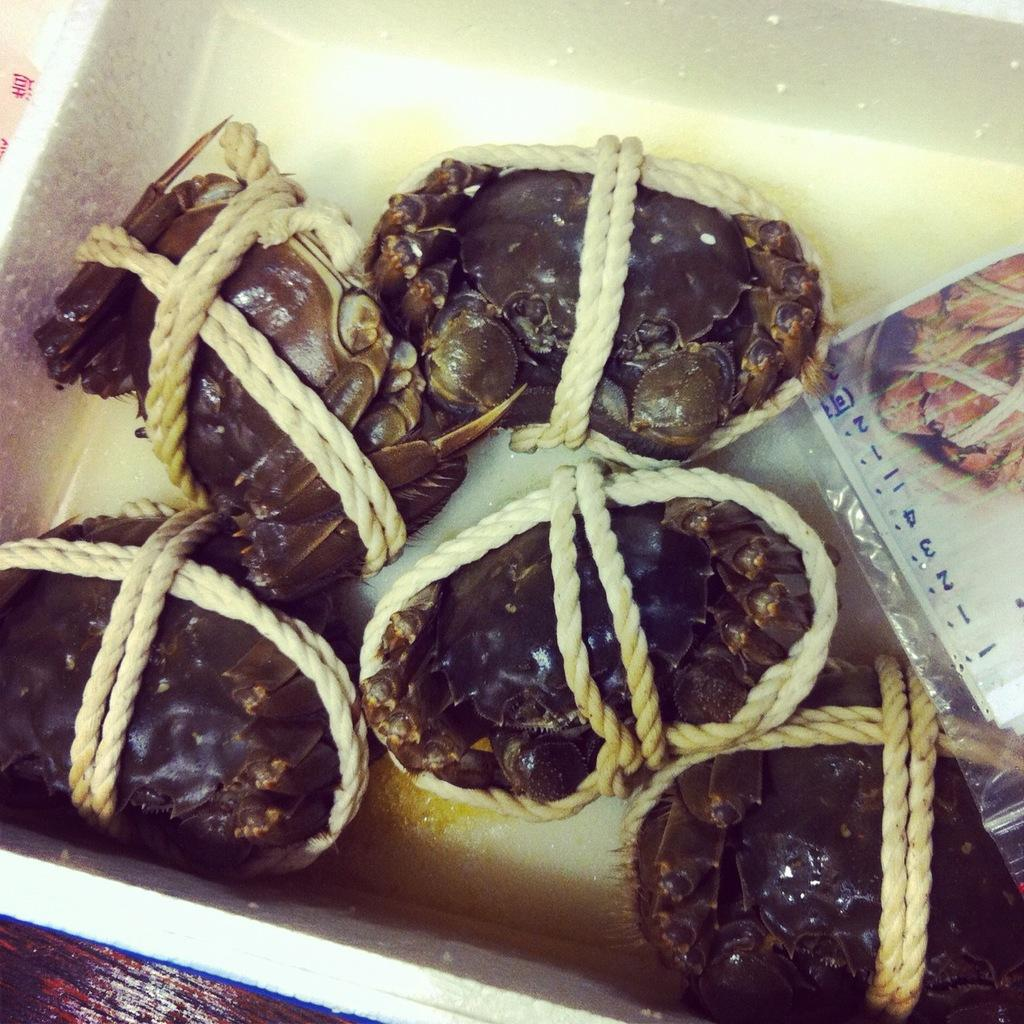What type of animals are present in the image? There are crabs in the image. How are the crabs secured or restrained? The crabs are tied with rope. Where are the crabs kept or stored? The crabs are kept in a basket. What additional object can be seen in the image? There is a paper in the image. What type of birds can be seen flying over the crabs in the image? There are no birds present in the image; it only features crabs, rope, a basket, and a paper. 